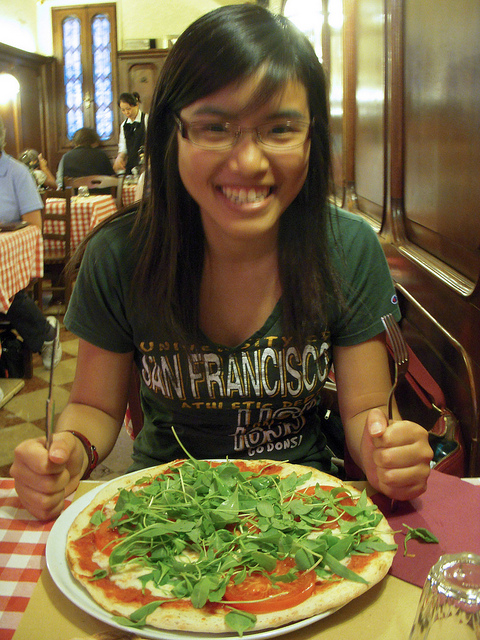Please extract the text content from this image. SAN FRANCLSCO GODONS 